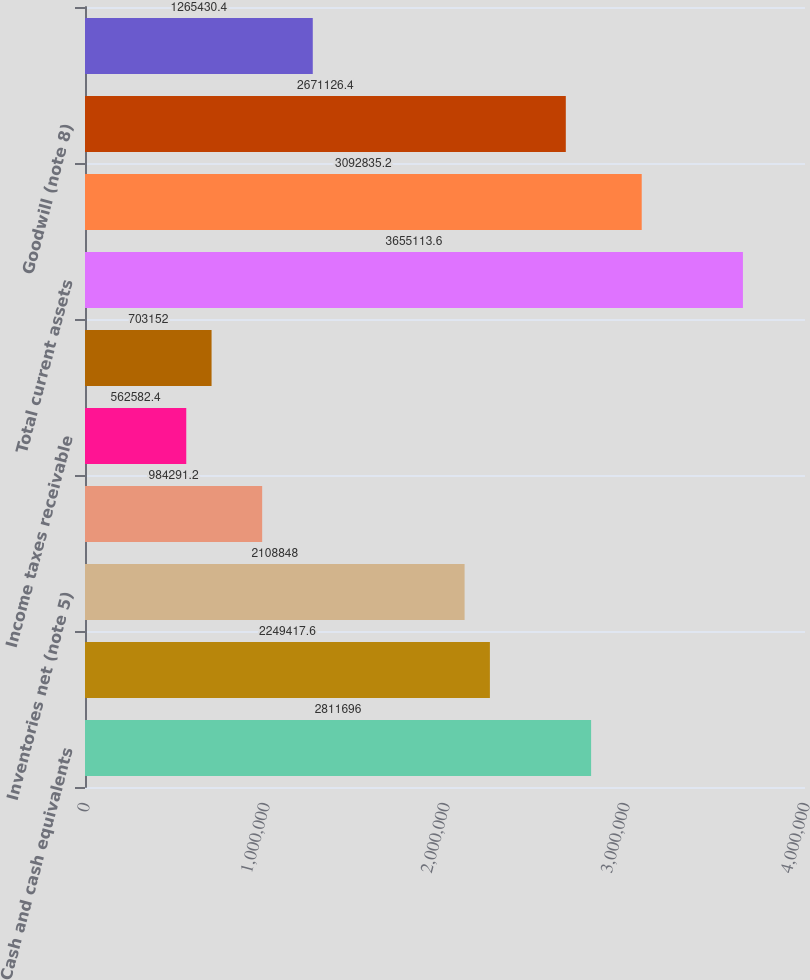Convert chart. <chart><loc_0><loc_0><loc_500><loc_500><bar_chart><fcel>Cash and cash equivalents<fcel>Accounts receivable net of<fcel>Inventories net (note 5)<fcel>Deferred income taxes (note<fcel>Income taxes receivable<fcel>Prepaid expenses and other<fcel>Total current assets<fcel>Property plant and equipment<fcel>Goodwill (note 8)<fcel>Other intangibles net (note 8)<nl><fcel>2.8117e+06<fcel>2.24942e+06<fcel>2.10885e+06<fcel>984291<fcel>562582<fcel>703152<fcel>3.65511e+06<fcel>3.09284e+06<fcel>2.67113e+06<fcel>1.26543e+06<nl></chart> 